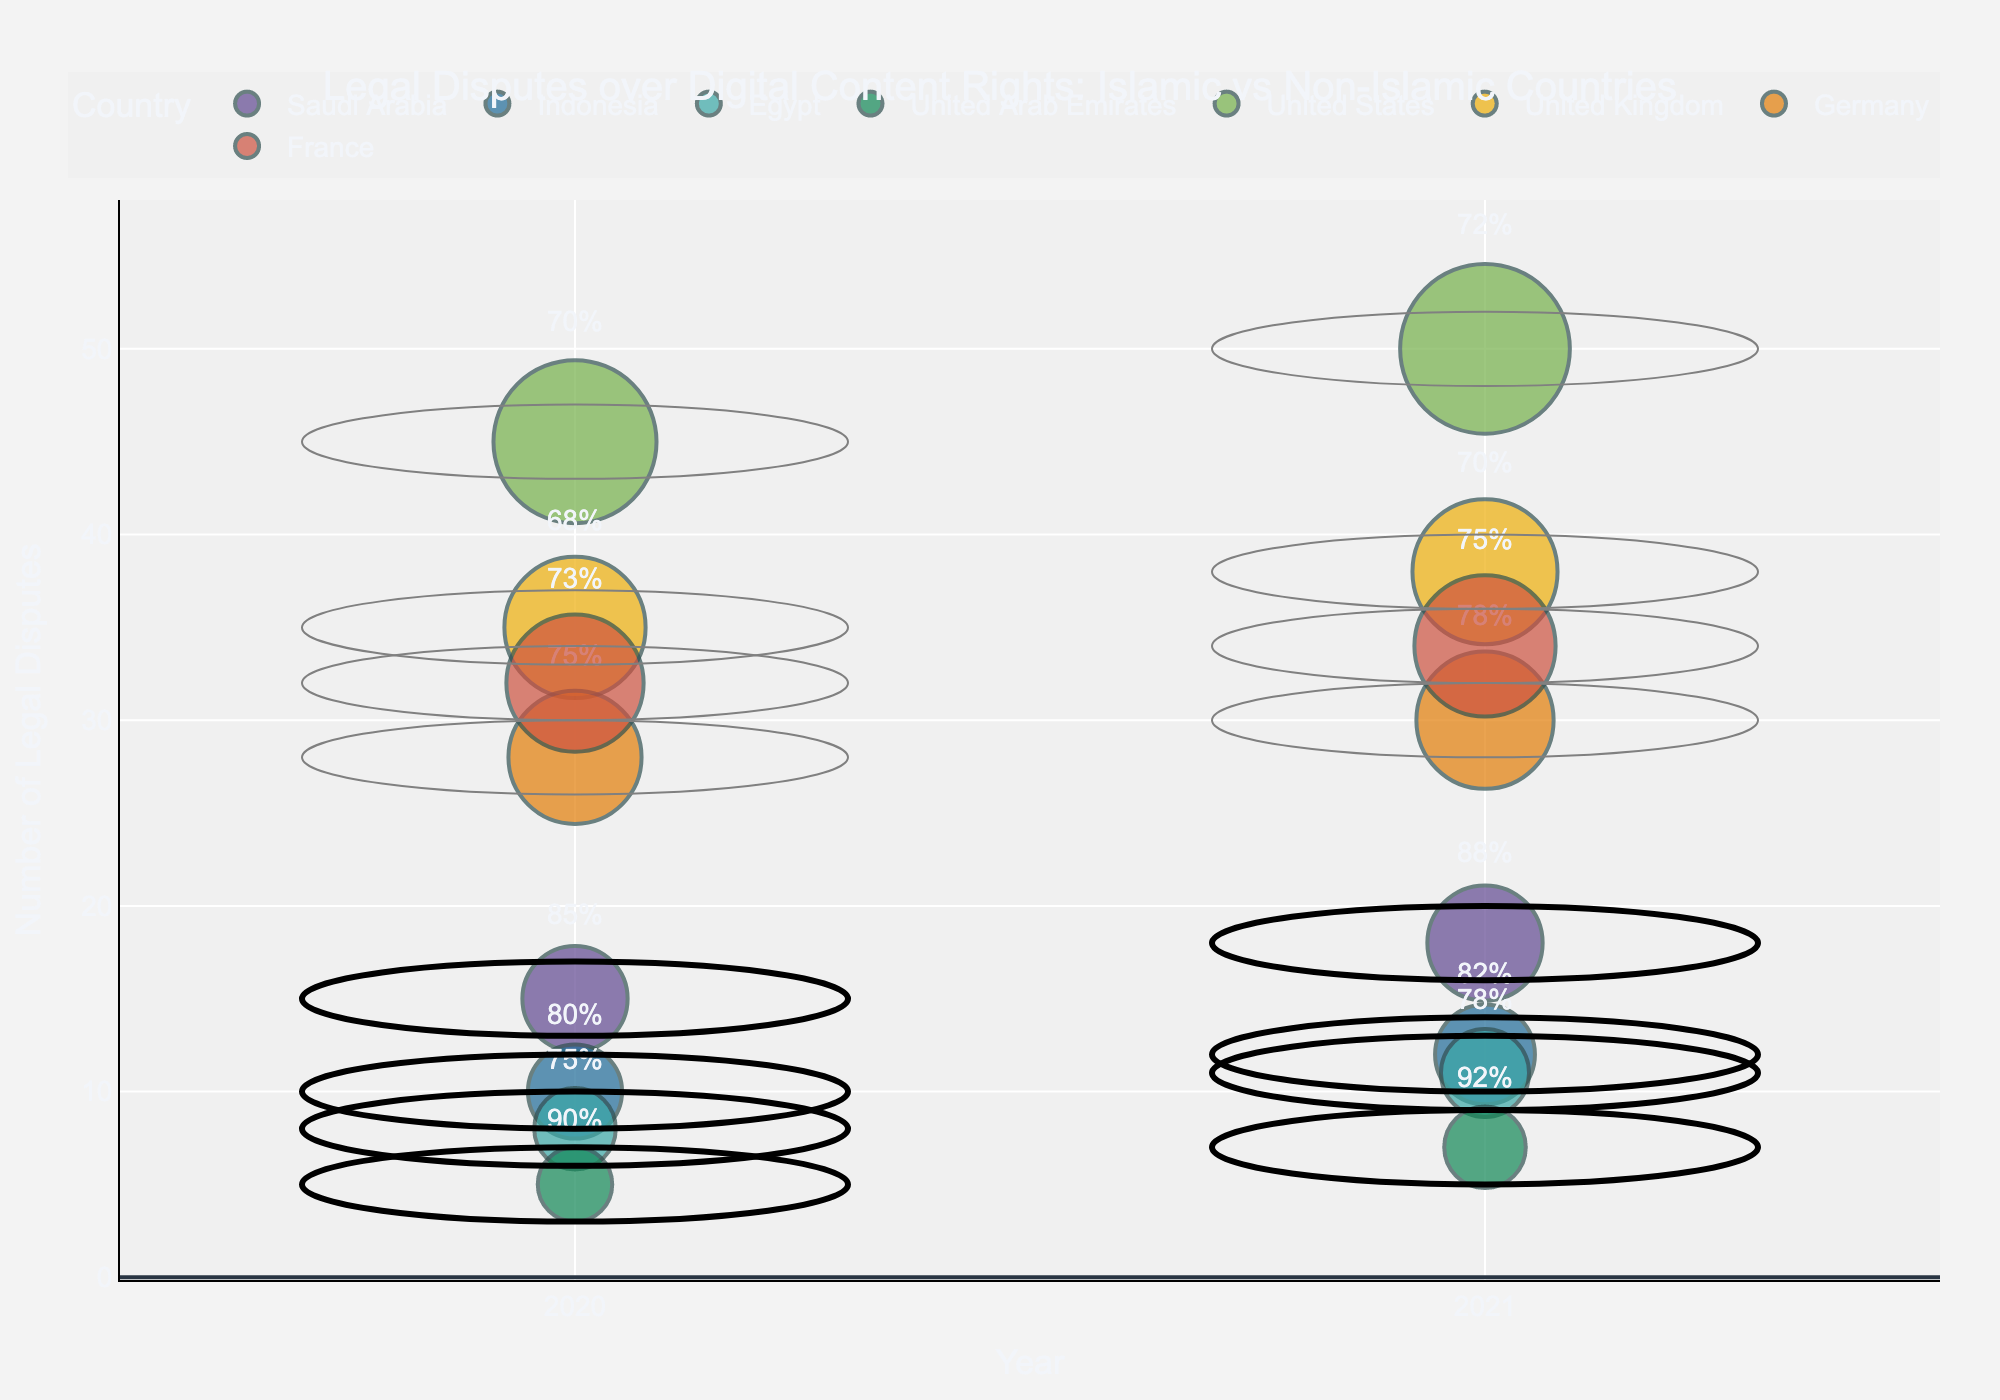What's the title of the figure? The title is usually located at the top-center of the figure. Reading the text there reveals the title.
Answer: Legal Disputes over Digital Content Rights: Islamic vs Non-Islamic Countries Which country had the highest number of disputes in 2021? Check the vertical axis (y-axis) for the highest point corresponding to year 2021 on the horizontal axis (x-axis). Hover over the data points or look for the labels.
Answer: United States How many legal disputes were recorded in Saudi Arabia in 2020? Locate Saudi Arabia on the colored markers, then check the year 2020 on the x-axis and read off the value on the y-axis.
Answer: 15 Which country showed the highest resolution rate in 2021 and what was it? Check the data points for year 2021 and look for the resolution rate text near the bubbles. Identify the highest resolution rate and its corresponding country.
Answer: United Arab Emirates, 0.92 Across all countries, did the number of disputes generally increase or decrease from 2020 to 2021? Compare the number of disputes in 2020 with those in 2021 for each country. Observe the overall trend of these numbers.
Answer: Increase What is the relationship between the size of the bubbles and the 'Population Affected'? The instruction or legend will describe that the bubble size represents the population affected. Larger bubbles indicate a larger population affected.
Answer: Larger bubble size indicates a larger population affected Which non-Islamic country had the most significant increase in the number of disputes from 2020 to 2021? Calculate the difference in the number of disputes for non-Islamic countries from 2020 to 2021 and compare them.
Answer: United States How do the resolution rates in Islamic countries compare to those in non-Islamic countries in 2021? Compare resolution rates by looking at the text next to each data point for 2021 and categorize them by Islamic and non-Islamic countries. Summarize the comparison.
Answer: Generally higher in Islamic countries What's the total number of legal disputes handled by the United States across both years? Add the number of disputes in 2020 and 2021 for the United States.
Answer: 95 Which country has shown consistent improvement in resolution rates from 2020 to 2021? Check the resolution rate for both 2020 and 2021 for each country and identify those with increasing resolution rates.
Answer: Saudi Arabia 